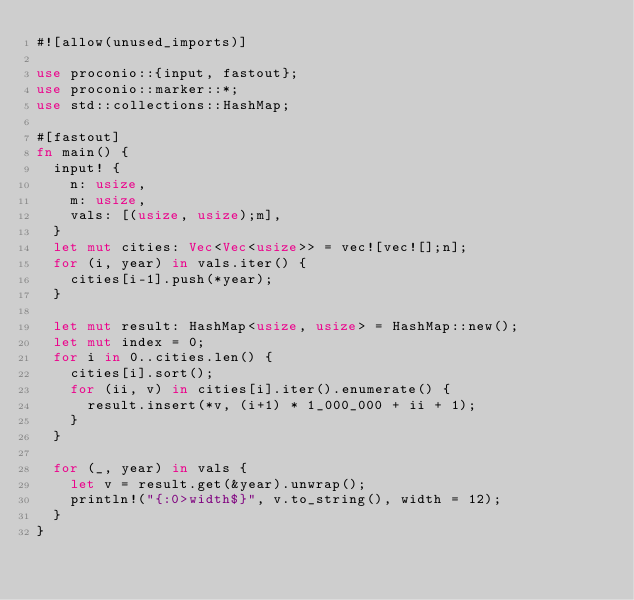<code> <loc_0><loc_0><loc_500><loc_500><_Rust_>#![allow(unused_imports)]
 
use proconio::{input, fastout};
use proconio::marker::*;
use std::collections::HashMap;
 
#[fastout]
fn main() {
  input! {
    n: usize,
    m: usize,
    vals: [(usize, usize);m],
  }
  let mut cities: Vec<Vec<usize>> = vec![vec![];n];
  for (i, year) in vals.iter() {
    cities[i-1].push(*year);
  }

  let mut result: HashMap<usize, usize> = HashMap::new();
  let mut index = 0;
  for i in 0..cities.len() {
    cities[i].sort();
    for (ii, v) in cities[i].iter().enumerate() {
      result.insert(*v, (i+1) * 1_000_000 + ii + 1);
    }
  }
  
  for (_, year) in vals {
    let v = result.get(&year).unwrap();
    println!("{:0>width$}", v.to_string(), width = 12); 
  }  
}</code> 